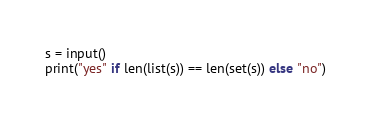Convert code to text. <code><loc_0><loc_0><loc_500><loc_500><_Python_>s = input()
print("yes" if len(list(s)) == len(set(s)) else "no")</code> 